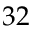<formula> <loc_0><loc_0><loc_500><loc_500>3 2</formula> 